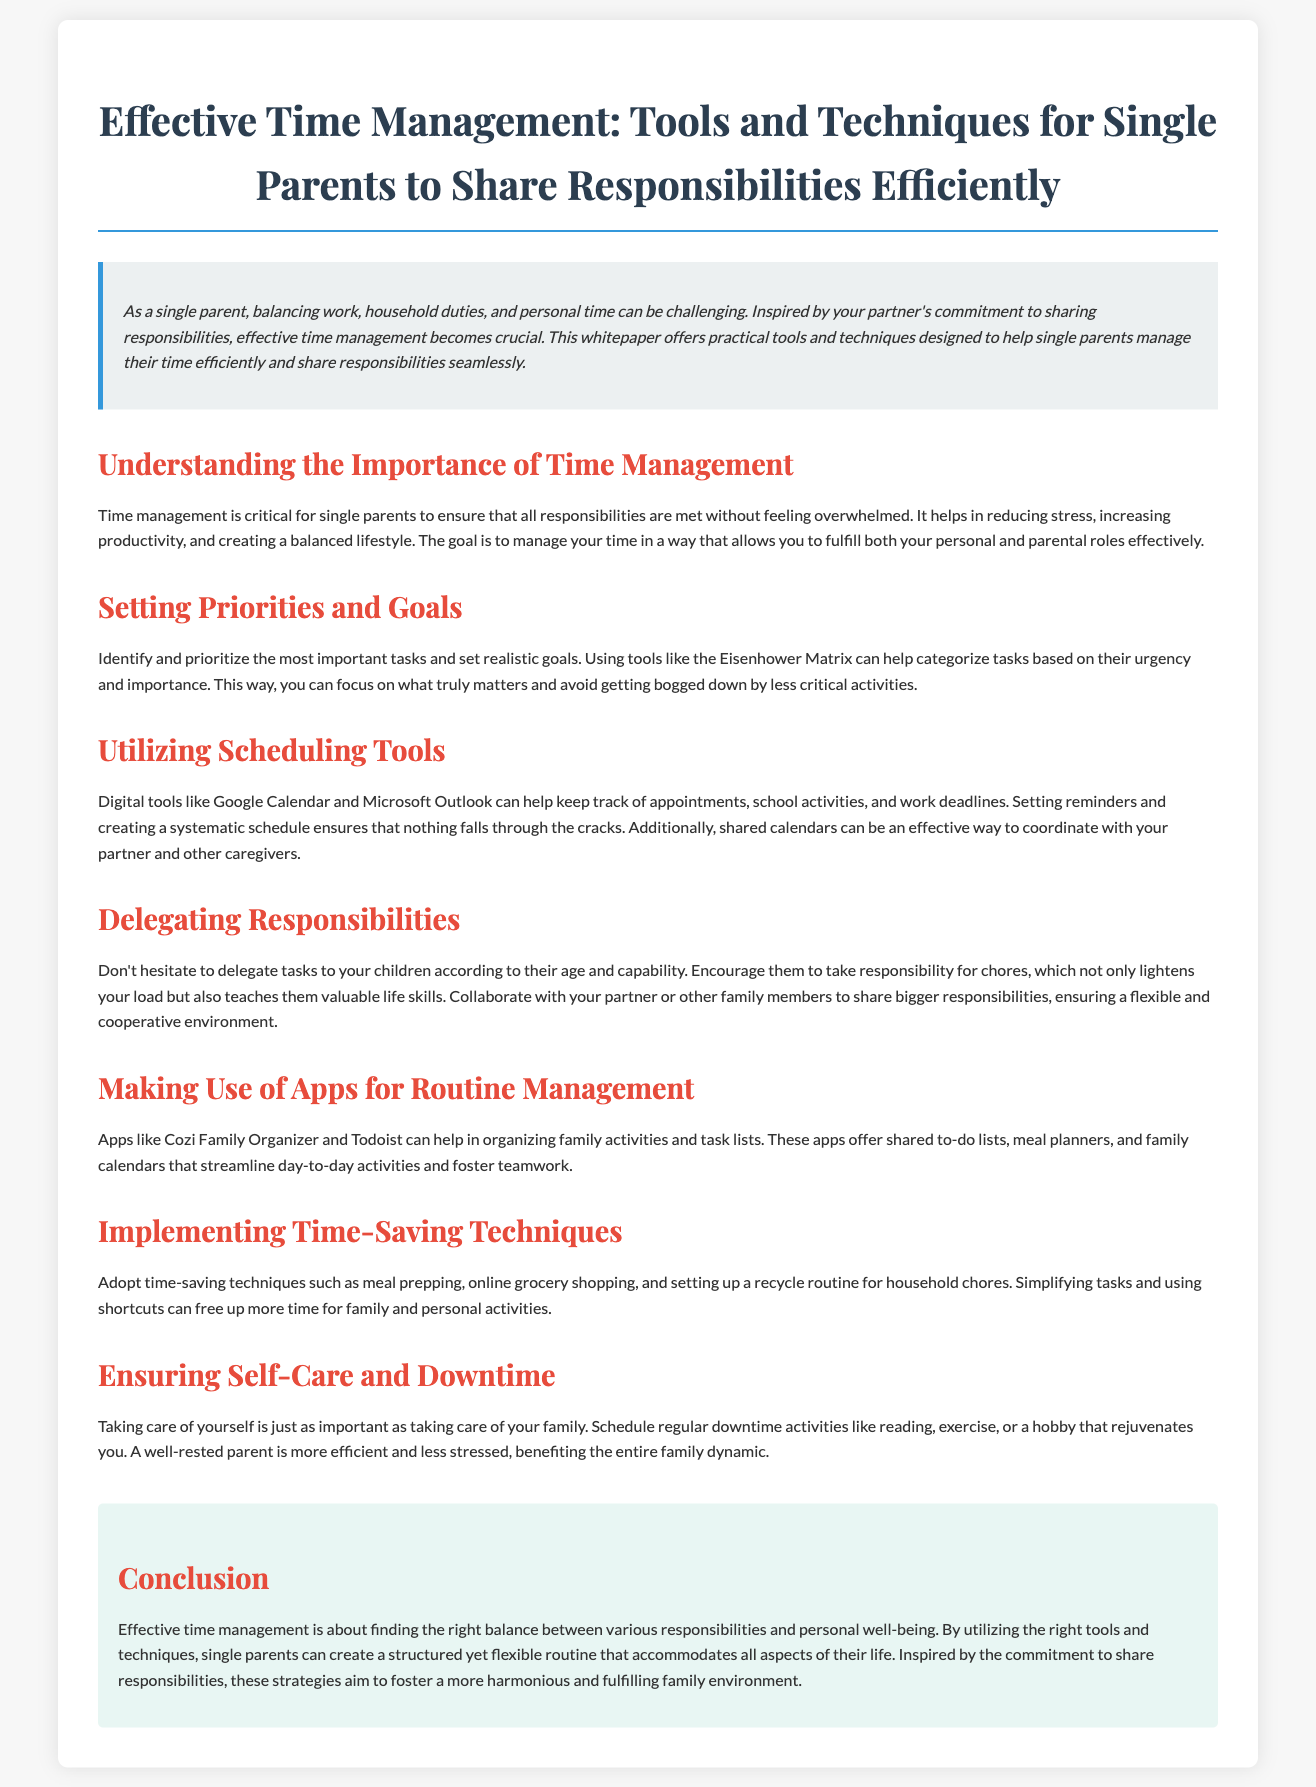What is the title of the whitepaper? The title of the whitepaper is mentioned at the top of the document.
Answer: Effective Time Management: Tools and Techniques for Single Parents to Share Responsibilities Efficiently What is one digital tool mentioned for scheduling? The document lists scheduling tools under a specific section, which includes digital tools.
Answer: Google Calendar What technique helps prioritize tasks? The document refers to a specific method for categorizing tasks and prioritizing them effectively.
Answer: Eisenhower Matrix What should single parents utilize to reduce stress? The importance of managing time is highlighted in a section that focuses on the benefits of effective time management for single parents.
Answer: Time management Which app is suggested for organizing family activities? The document refers to specific apps that aid in organization, including one for family activities.
Answer: Cozi Family Organizer How does delegating tasks benefit children? The section on delegating responsibilities explains a benefit of assigning chores to children.
Answer: Teaches them valuable life skills What is emphasized as important for personal well-being? The conclusion section describes a particular aspect that is equally important as caring for the family.
Answer: Self-care What is the primary goal of effective time management for single parents? The document outlines the overall intention behind managing time well in one of its sections.
Answer: Create a balanced lifestyle 